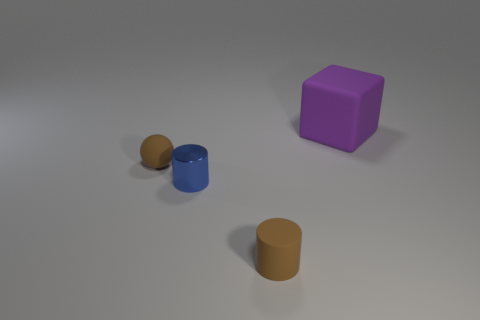Add 1 large gray matte spheres. How many objects exist? 5 Subtract all brown cylinders. How many cylinders are left? 1 Subtract 0 cyan balls. How many objects are left? 4 Subtract all blocks. How many objects are left? 3 Subtract all red cylinders. Subtract all gray blocks. How many cylinders are left? 2 Subtract all blue blocks. How many blue cylinders are left? 1 Subtract all small metallic cylinders. Subtract all brown shiny blocks. How many objects are left? 3 Add 4 small cylinders. How many small cylinders are left? 6 Add 4 green shiny cylinders. How many green shiny cylinders exist? 4 